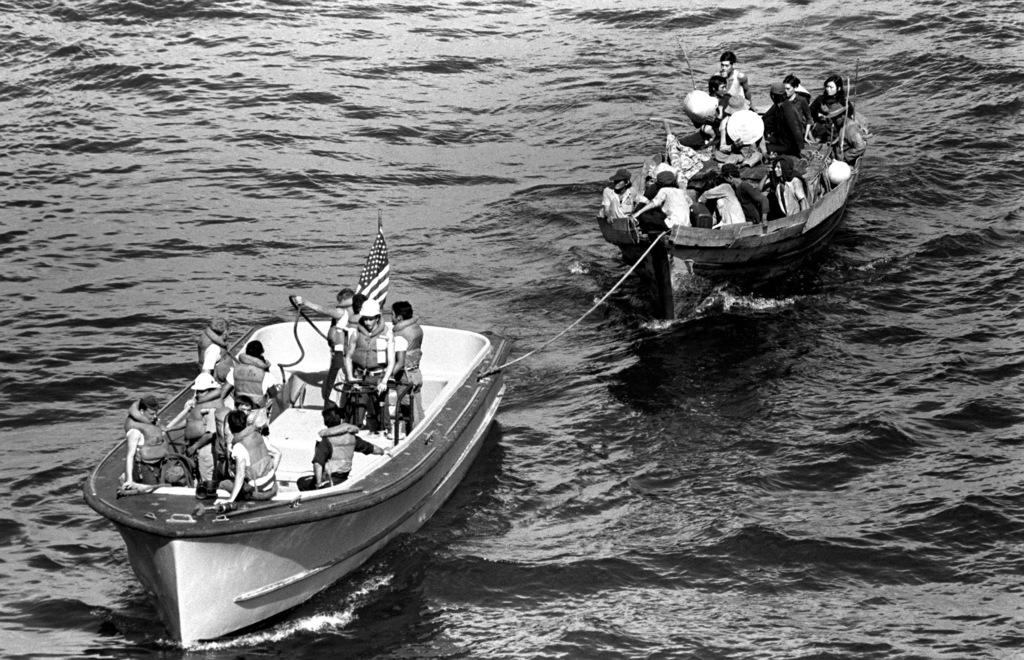What is the color scheme of the image? The image is black and white. What activity are the people engaged in within the image? People are sailing boats in the image. What natural element is present in the image? There is water visible in the image. What additional detail can be observed in the image? There is a flag in the image. How much honey is being used by the people sailing boats in the image? There is no honey present in the image, as it features people sailing boats in water. What type of memory is being stored in the image? There is no reference to memory storage in the image; it depicts people sailing boats in water. 